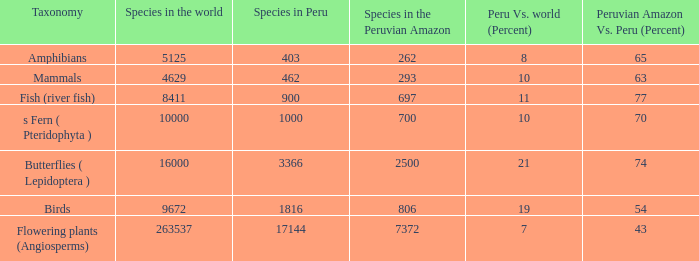What's the species in the world with peruvian amazon vs. peru (percent)  of 63 4629.0. 